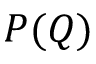Convert formula to latex. <formula><loc_0><loc_0><loc_500><loc_500>P ( Q )</formula> 